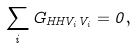Convert formula to latex. <formula><loc_0><loc_0><loc_500><loc_500>\sum _ { i } G _ { H H V _ { i } V _ { i } } = 0 ,</formula> 